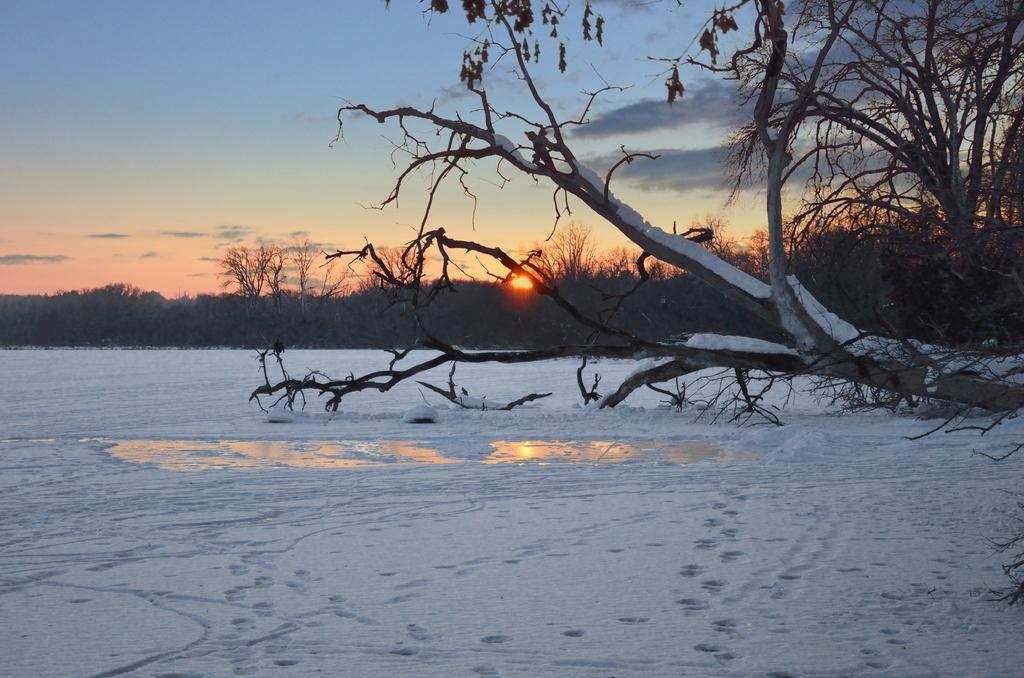Can you describe this image briefly? In this image there is the sky towards the top of the image, there is the sun on the sky, there are trees, there is snow on the tree, there is water on the ground, there is snow on the ground. 